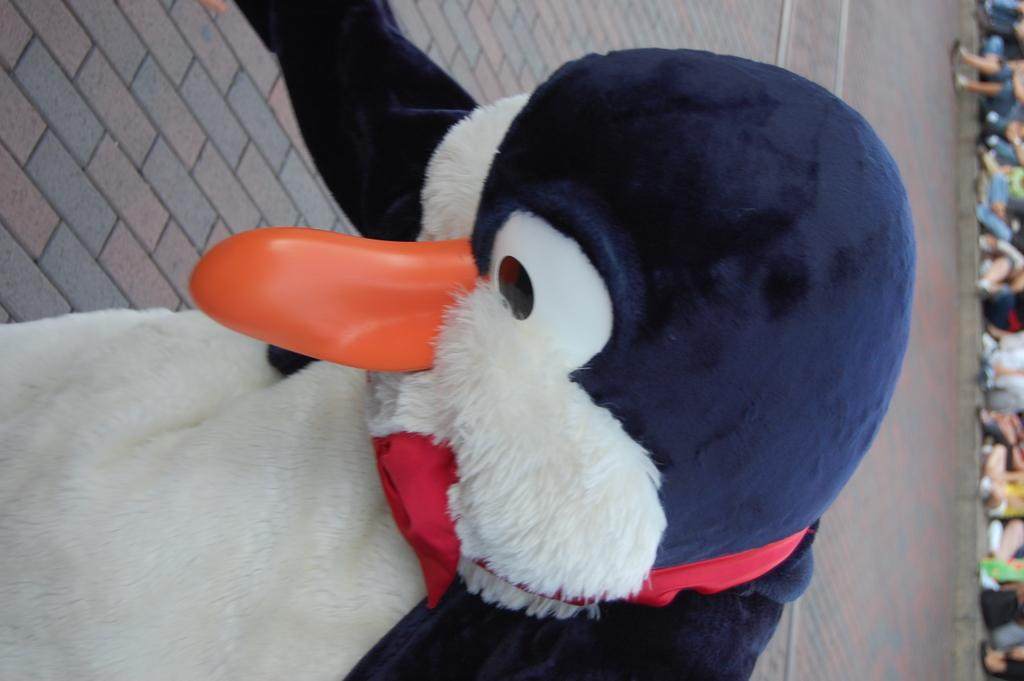What is the main subject of the image? There is a person in the image. What is the person wearing? The person is wearing a costume of a penguin. Can you describe the background of the image? The background of the image is blurry. How many hens are visible in the image? There are no hens present in the image. What type of crate is being used to transport the penguin costume? There is no crate present in the image, and the penguin costume is being worn by the person. 